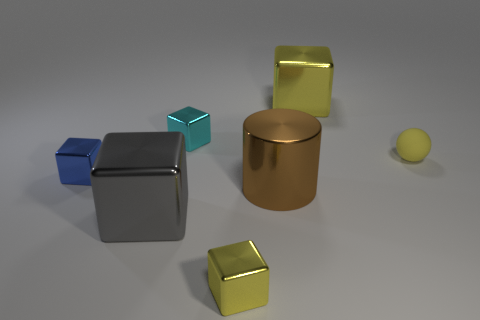Subtract all green cylinders. How many yellow blocks are left? 2 Subtract all small cyan metal cubes. How many cubes are left? 4 Subtract all blue cubes. How many cubes are left? 4 Add 1 tiny yellow rubber balls. How many objects exist? 8 Subtract all green cubes. Subtract all purple balls. How many cubes are left? 5 Subtract all blocks. How many objects are left? 2 Subtract 0 purple spheres. How many objects are left? 7 Subtract all small matte objects. Subtract all big metallic cubes. How many objects are left? 4 Add 2 small yellow metal objects. How many small yellow metal objects are left? 3 Add 3 large gray things. How many large gray things exist? 4 